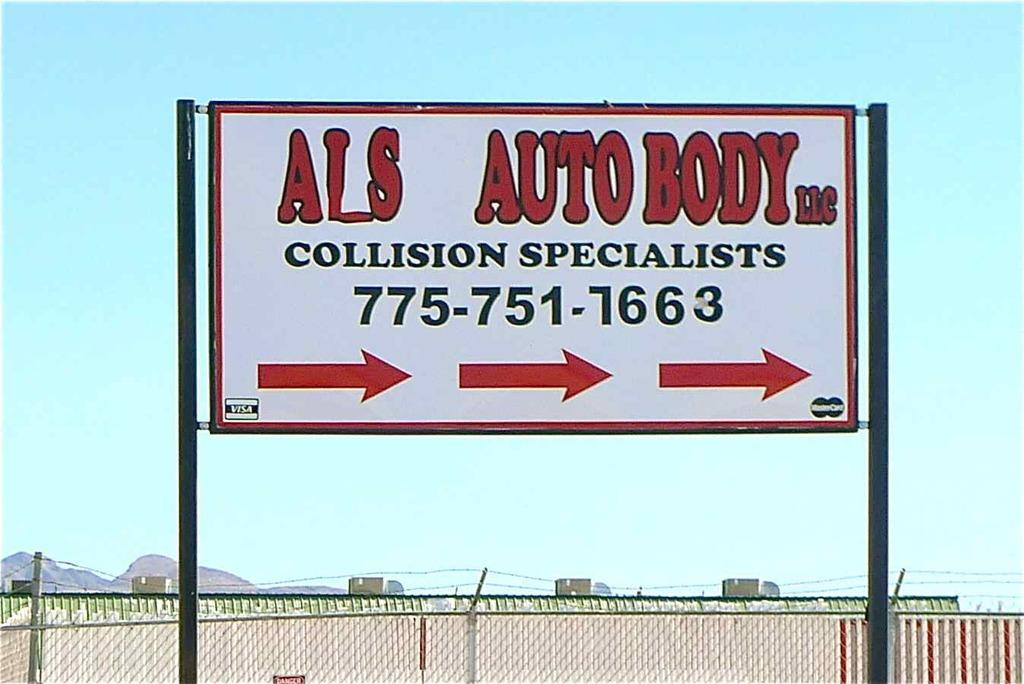<image>
Offer a succinct explanation of the picture presented. ALS Auto Body can be found to the right. 